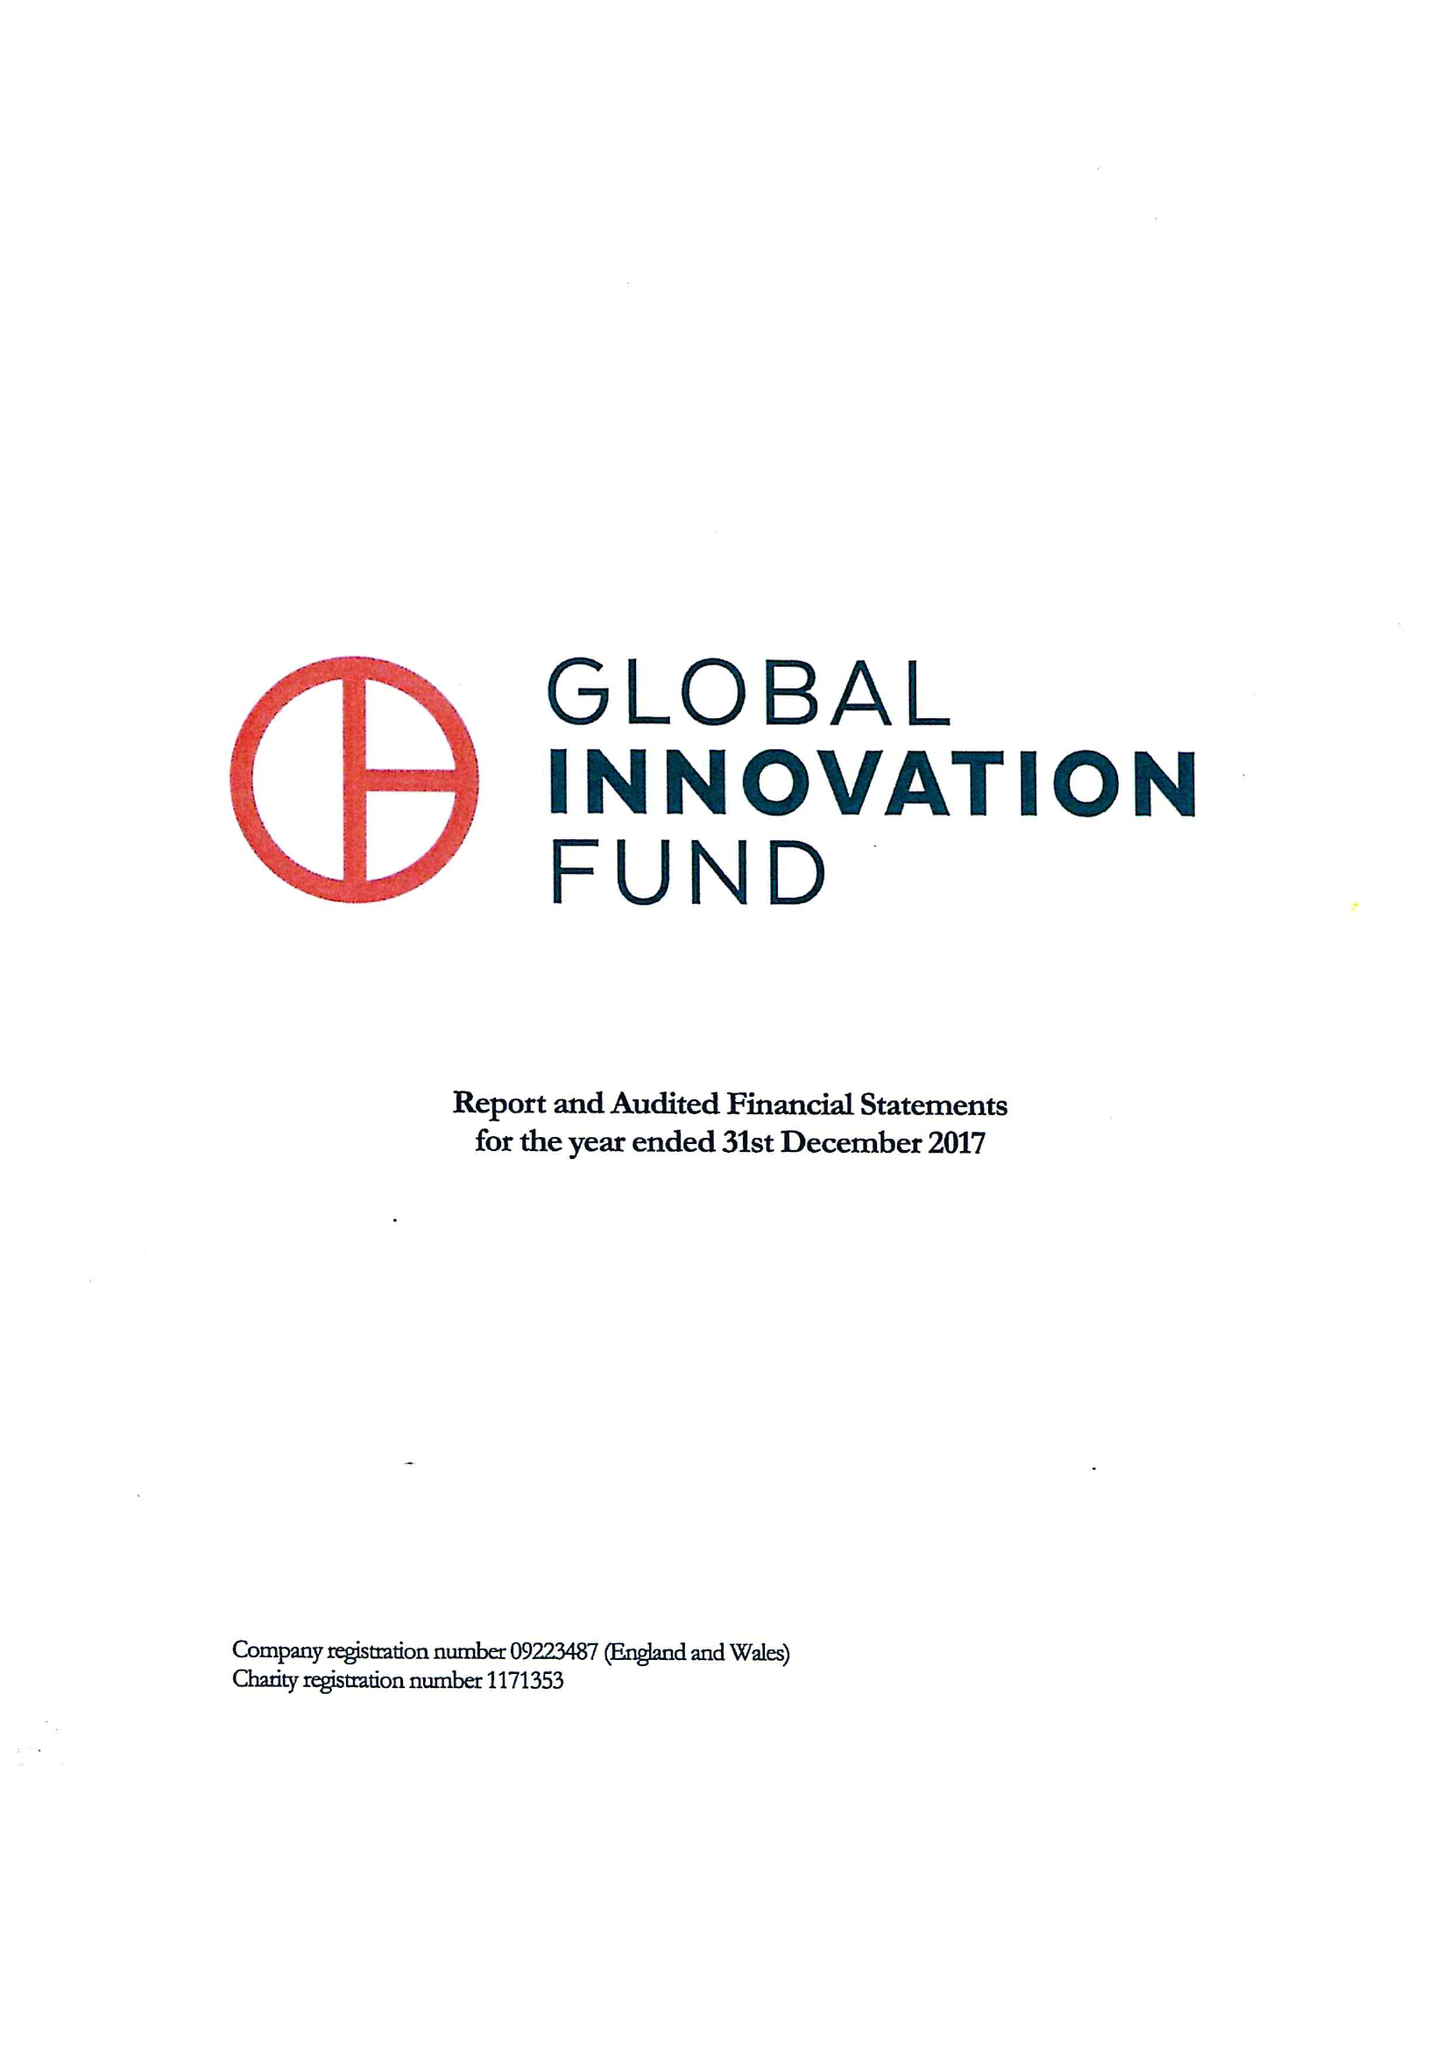What is the value for the charity_name?
Answer the question using a single word or phrase. Global Innovation Fund 